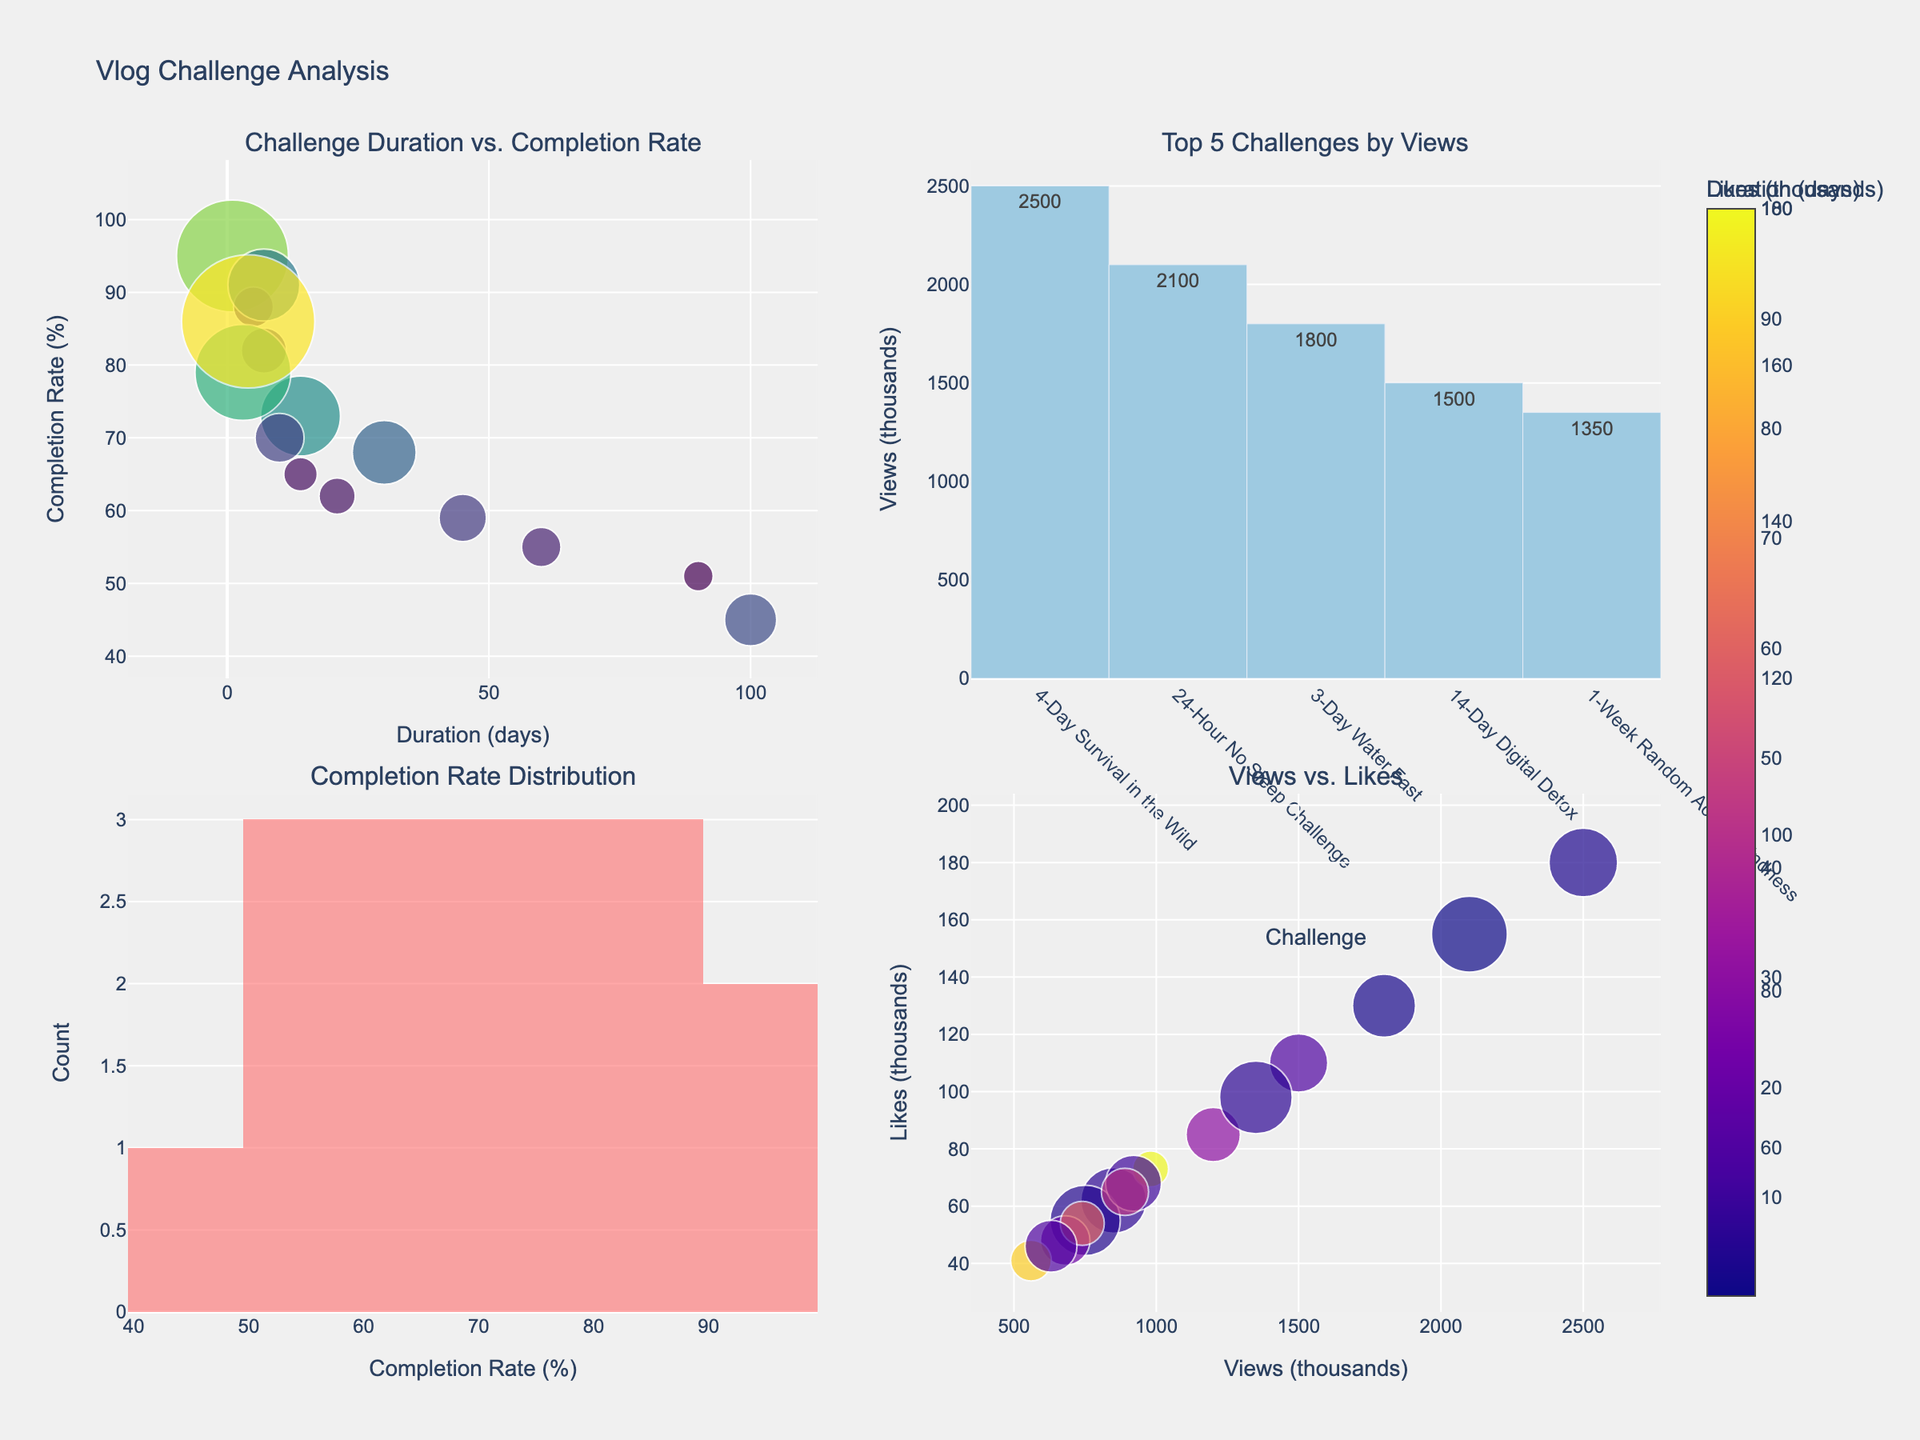What is the title of the figure? The title of the figure is found at the top of the visualization, it reads "Vlog Challenge Analysis".
Answer: Vlog Challenge Analysis What does the x-axis represent in the top-left scatter plot? The x-axis in the scatter plot (top-left) represents the "Duration (days)" of each vlog challenge.
Answer: Duration (days) Which challenge has the highest completion rate? In the top-left scatter plot, the data point furthest up on the y-axis represents the 24-Hour No Sleep Challenge, indicating it has the highest completion rate of 95%.
Answer: 24-Hour No Sleep Challenge What is the range of the completion rates for the challenges? In the histogram (bottom-left), the completion rate ranges from the lowest bin (45%) to the highest bin (95%).
Answer: 45%-95% Which challenge has the most views? In the top 5 bar chart (top-right), the highest bar represents the 24-Hour No Sleep Challenge with 2100 thousand views.
Answer: 24-Hour No Sleep Challenge Which color scale is used for likes in the scatter plot of Duration vs. Completion Rate? The color of data points in the scatter plot (top-left) is based on likes, and the color scale used is 'Viridis'.
Answer: Viridis What challenge has the most likes among the top 5 challenges by views? The top 5 challenges by views are in the top-right bar chart, and the challenge with the most likes is the 24-Hour No Sleep Challenge with 155 thousand likes.
Answer: 24-Hour No Sleep Challenge How many challenges have a duration of less than 10 days? In the top-left scatter plot, count the data points with x-values less than 10. These are: 7-Day Vegan Diet, 24-Hour No Sleep Challenge, 5-Day Cold Shower Challenge, 3-Day Water Fast, 7-Day Random Acts of Kindness, and 4-Day Survival in the Wild, totaling 6 challenges.
Answer: 6 Is there a correlation between views and likes? In the scatter plot (bottom-right), we observe that as views increase, likes tend to also increase, indicating a positive correlation.
Answer: Yes Which challenge with a duration over 30 days has the highest completion rate? Looking at the top-left scatter plot focusing on points with durations over 30 days, the 60-Day No Sugar Challenge (60 days) has the highest completion rate of 55%.
Answer: 60-Day No Sugar Challenge 